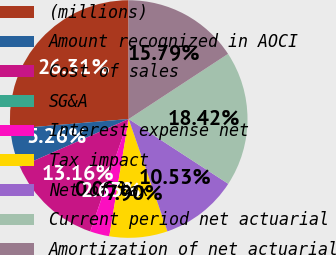Convert chart. <chart><loc_0><loc_0><loc_500><loc_500><pie_chart><fcel>(millions)<fcel>Amount recognized in AOCI<fcel>Cost of sales<fcel>SG&A<fcel>Interest expense net<fcel>Tax impact<fcel>Net of tax<fcel>Current period net actuarial<fcel>Amortization of net actuarial<nl><fcel>26.31%<fcel>5.26%<fcel>13.16%<fcel>0.0%<fcel>2.63%<fcel>7.9%<fcel>10.53%<fcel>18.42%<fcel>15.79%<nl></chart> 